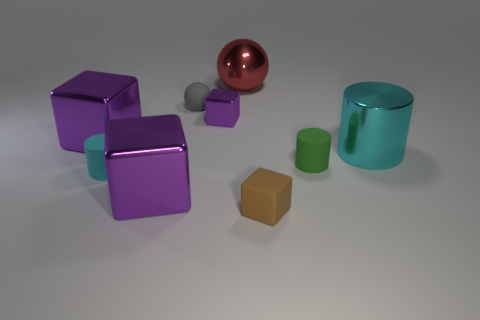What could be the purpose of creating this image? The purpose of creating this image could be multiple-fold. It might be used as a visual test for rendering techniques, demonstrating the effects of light on objects with different colors and materials. Alternatively, it could serve an educational purpose to teach about shapes, colors, and light in a visual arts context, or it could be part of a catalog or portfolio showcasing a 3D artist's skills. 